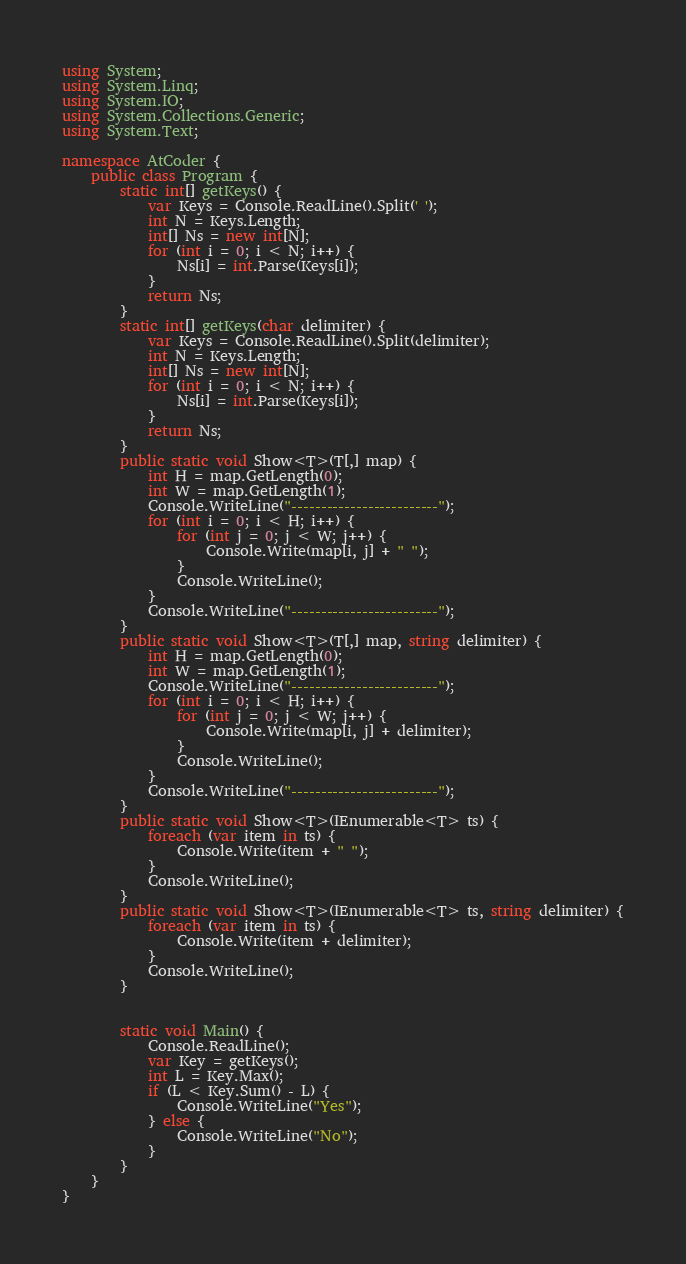<code> <loc_0><loc_0><loc_500><loc_500><_C#_>using System;
using System.Linq;
using System.IO;
using System.Collections.Generic;
using System.Text;

namespace AtCoder {
    public class Program {
        static int[] getKeys() {
            var Keys = Console.ReadLine().Split(' ');
            int N = Keys.Length;
            int[] Ns = new int[N];
            for (int i = 0; i < N; i++) {
                Ns[i] = int.Parse(Keys[i]);
            }
            return Ns;
        }
        static int[] getKeys(char delimiter) {
            var Keys = Console.ReadLine().Split(delimiter);
            int N = Keys.Length;
            int[] Ns = new int[N];
            for (int i = 0; i < N; i++) {
                Ns[i] = int.Parse(Keys[i]);
            }
            return Ns;
        }
        public static void Show<T>(T[,] map) {
            int H = map.GetLength(0);
            int W = map.GetLength(1);
            Console.WriteLine("-------------------------");
            for (int i = 0; i < H; i++) {
                for (int j = 0; j < W; j++) {
                    Console.Write(map[i, j] + " ");
                }
                Console.WriteLine();
            }
            Console.WriteLine("-------------------------");
        }
        public static void Show<T>(T[,] map, string delimiter) {
            int H = map.GetLength(0);
            int W = map.GetLength(1);
            Console.WriteLine("-------------------------");
            for (int i = 0; i < H; i++) {
                for (int j = 0; j < W; j++) {
                    Console.Write(map[i, j] + delimiter);
                }
                Console.WriteLine();
            }
            Console.WriteLine("-------------------------");
        }
        public static void Show<T>(IEnumerable<T> ts) {
            foreach (var item in ts) {
                Console.Write(item + " ");
            }
            Console.WriteLine();
        }
        public static void Show<T>(IEnumerable<T> ts, string delimiter) {
            foreach (var item in ts) {
                Console.Write(item + delimiter);
            }
            Console.WriteLine();
        }


        static void Main() {
            Console.ReadLine();
            var Key = getKeys();
            int L = Key.Max();
            if (L < Key.Sum() - L) {
                Console.WriteLine("Yes");
            } else {
                Console.WriteLine("No");
            }
        }
    }
}
</code> 